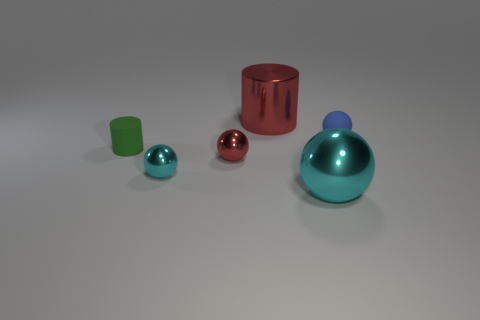Subtract 1 balls. How many balls are left? 3 Subtract all green balls. Subtract all brown cylinders. How many balls are left? 4 Add 3 matte things. How many objects exist? 9 Subtract all balls. How many objects are left? 2 Subtract 0 green cubes. How many objects are left? 6 Subtract all small red blocks. Subtract all spheres. How many objects are left? 2 Add 5 blue matte objects. How many blue matte objects are left? 6 Add 1 large gray shiny cylinders. How many large gray shiny cylinders exist? 1 